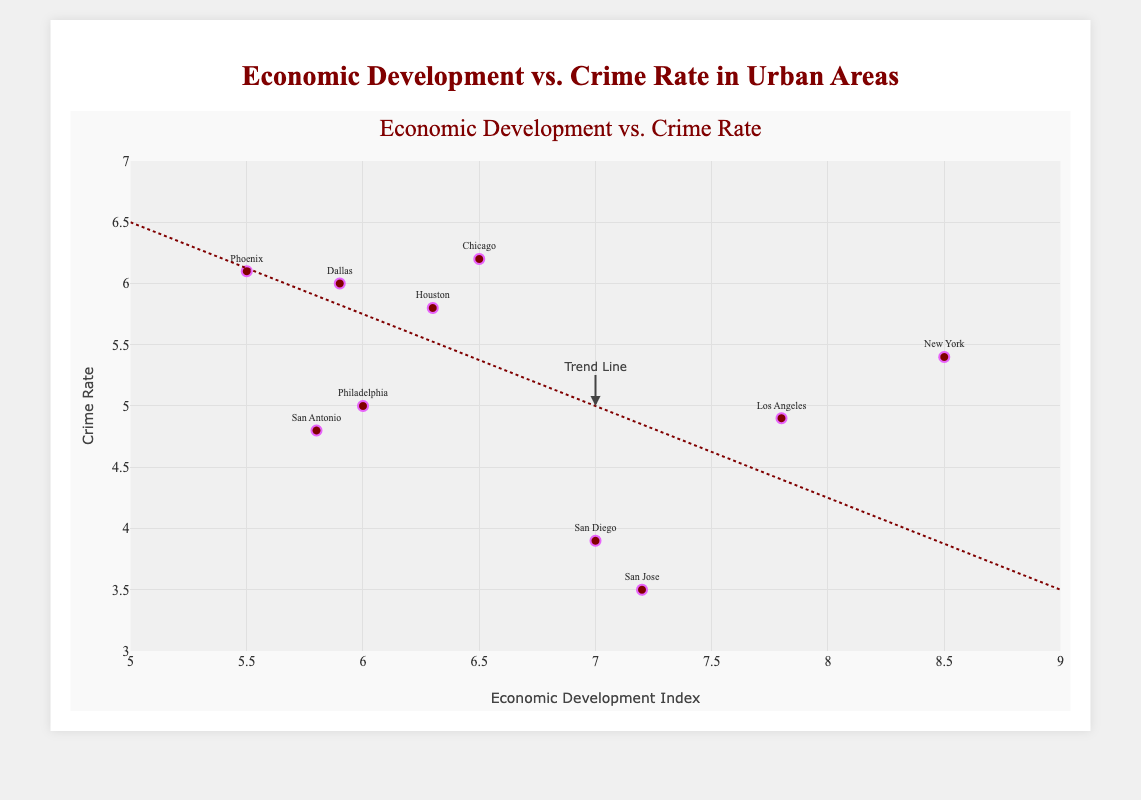What's the title of the figure? The title is written at the top of the figure. It is "Economic Development vs. Crime Rate in Urban Areas."
Answer: Economic Development vs. Crime Rate in Urban Areas How many cities are represented in the figure? Each city is marked by a data point on the scatter plot. Counting each point, we see there are 10 cities.
Answer: 10 Which city has the highest economic development index? The city with the highest economic development index will have the rightmost position on the x-axis. According to the plot, New York has the highest index of 8.5.
Answer: New York What's the crime rate for the city with the highest economic development index? The crime rate for the city with the highest economic development index (New York) can be found by looking at the y-axis where its data point lies. The crime rate is 5.4.
Answer: 5.4 Which city has the lowest crime rate and what is its economic development index? The city with the lowest crime rate will have the lowest position on the y-axis. San Jose has the lowest crime rate of 3.5, and its economic development index is 7.2.
Answer: San Jose, 7.2 What is the general trend of the relationship between economic development and crime rate? The trend is represented by the dotted trend line which slopes downwards from left to right. This indicates that higher economic development is generally associated with lower crime rates.
Answer: Higher economic development, lower crime rates Compare the crime rates of Los Angeles and Chicago. Los Angeles has a crime rate of 4.9, and Chicago has a crime rate of 6.2. Comparing these, Los Angeles has a lower crime rate than Chicago.
Answer: Los Angeles has a lower crime rate than Chicago Calculate the average economic development index for all cities. Sum the economic development indices for all cities and divide by the number of cities: (8.5 + 7.8 + 6.5 + 6.3 + 5.5 + 6.0 + 5.8 + 7.0 + 5.9 + 7.2) / 10 = 66.5 / 10 = 6.65
Answer: 6.65 Which city is closest to the trend line with its crime rate and economic development index? To find the city closest to the trend line, visually identify the data point nearest to the line. San Diego appears to be the closest to the trend line with a crime rate of 3.9 and an economic development index of 7.0.
Answer: San Diego 